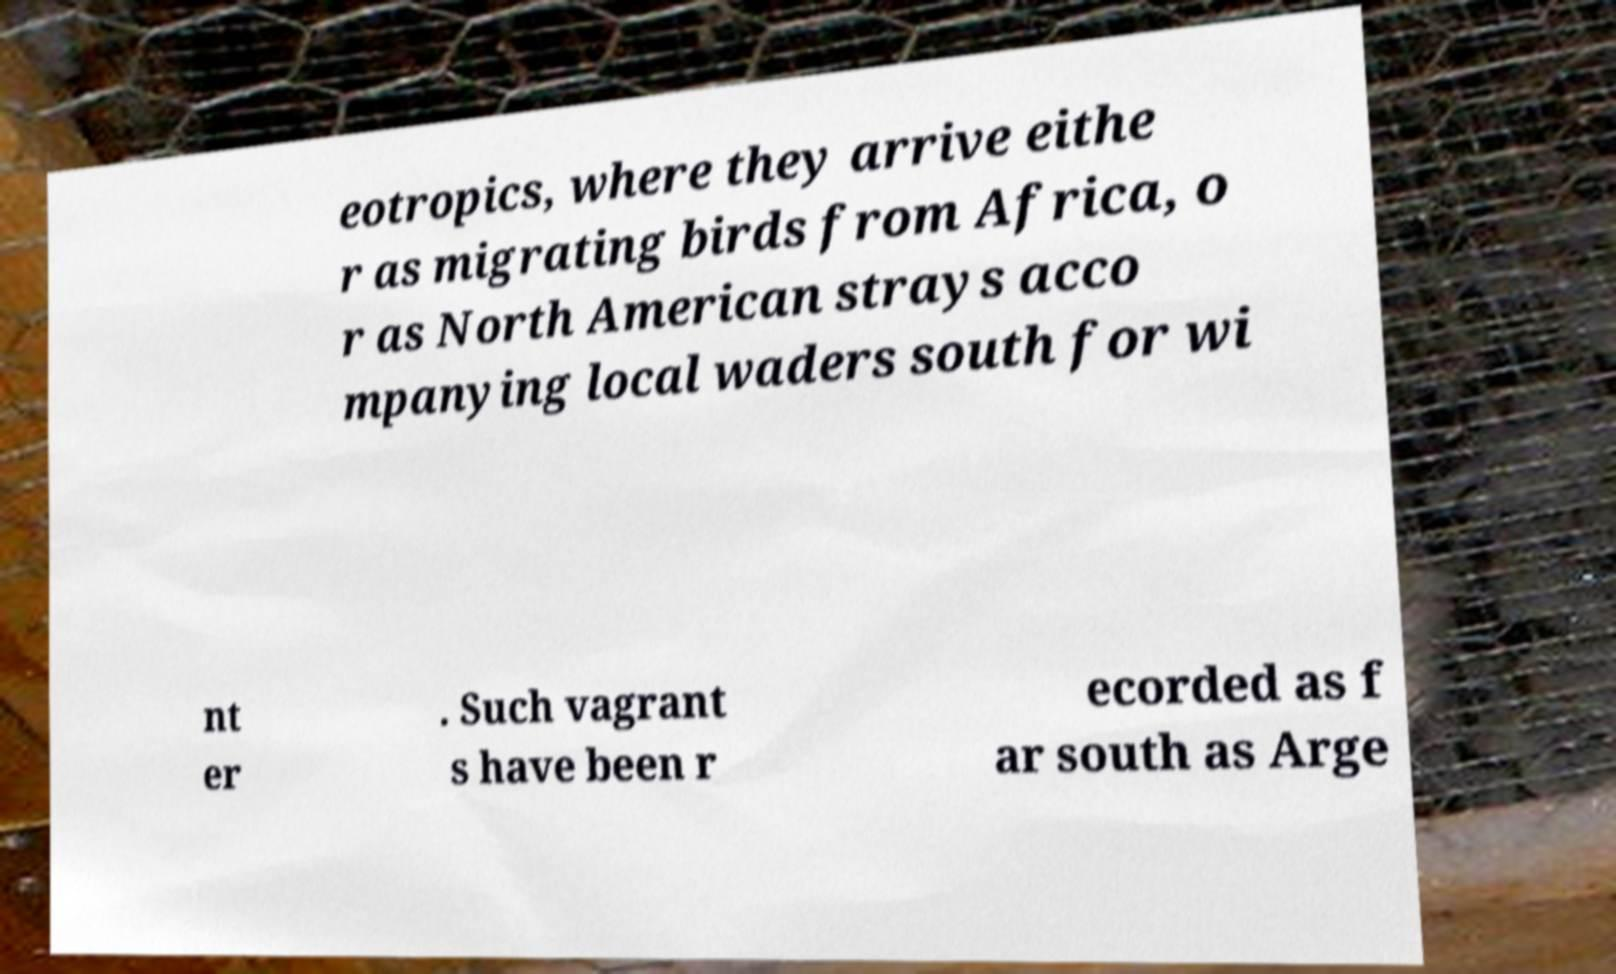Can you read and provide the text displayed in the image?This photo seems to have some interesting text. Can you extract and type it out for me? eotropics, where they arrive eithe r as migrating birds from Africa, o r as North American strays acco mpanying local waders south for wi nt er . Such vagrant s have been r ecorded as f ar south as Arge 